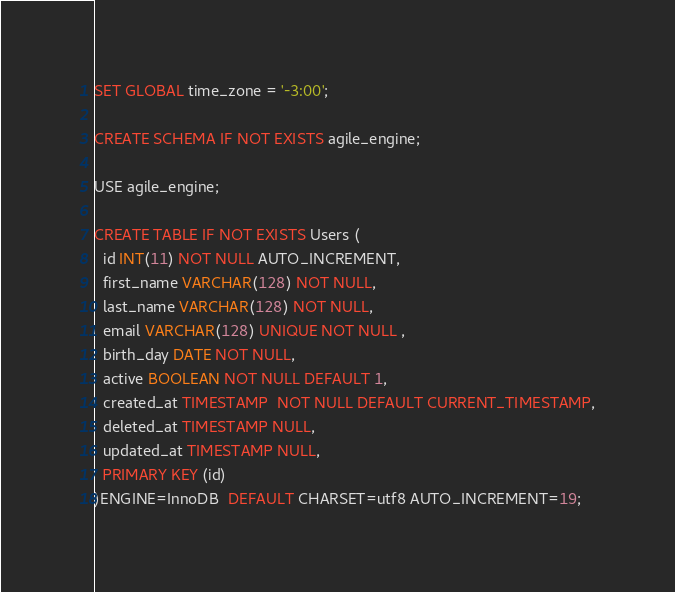<code> <loc_0><loc_0><loc_500><loc_500><_SQL_>SET GLOBAL time_zone = '-3:00';

CREATE SCHEMA IF NOT EXISTS agile_engine;

USE agile_engine;

CREATE TABLE IF NOT EXISTS Users (
  id INT(11) NOT NULL AUTO_INCREMENT,
  first_name VARCHAR(128) NOT NULL,
  last_name VARCHAR(128) NOT NULL,
  email VARCHAR(128) UNIQUE NOT NULL ,
  birth_day DATE NOT NULL,
  active BOOLEAN NOT NULL DEFAULT 1,
  created_at TIMESTAMP  NOT NULL DEFAULT CURRENT_TIMESTAMP,
  deleted_at TIMESTAMP NULL,
  updated_at TIMESTAMP NULL,
  PRIMARY KEY (id)
)ENGINE=InnoDB  DEFAULT CHARSET=utf8 AUTO_INCREMENT=19;</code> 